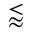<formula> <loc_0><loc_0><loc_500><loc_500>\lessapprox</formula> 